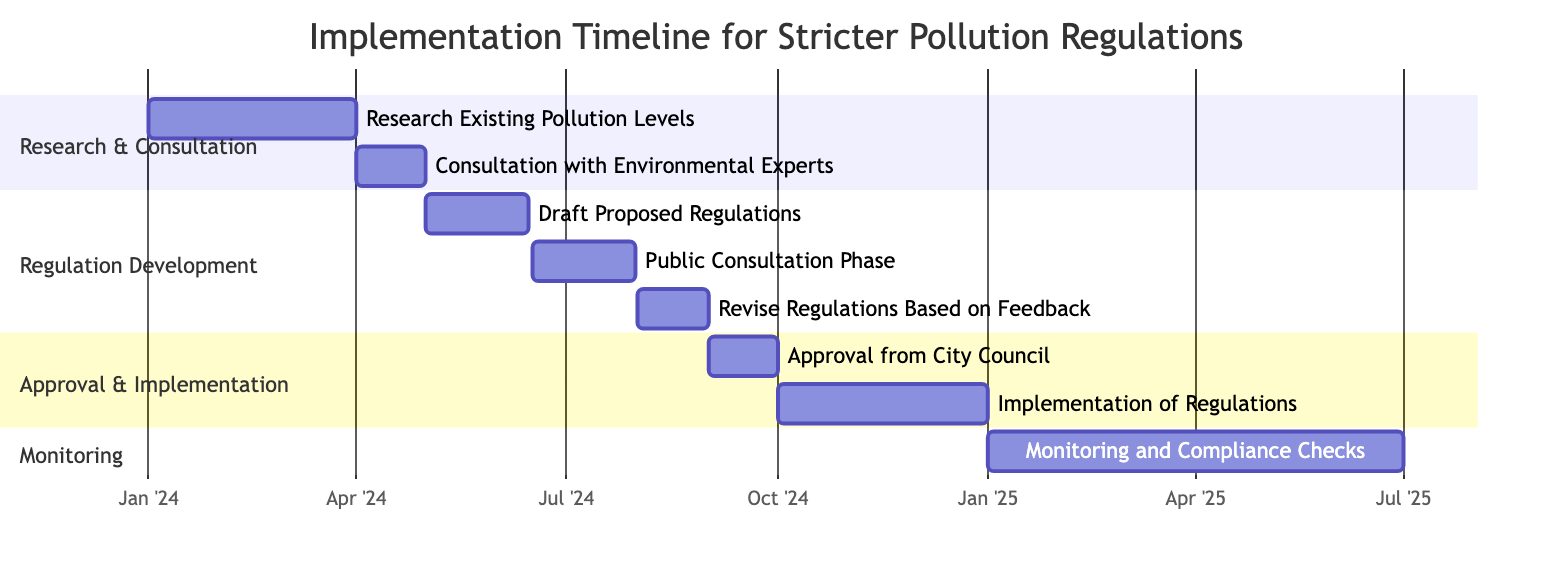What is the duration of the "Research Existing Pollution Levels" task? The "Research Existing Pollution Levels" task starts on January 1, 2024, and ends on March 31, 2024. Therefore, the duration is from January to March, which is 3 months.
Answer: 3 months How many tasks are there in the "Approval & Implementation" section? The "Approval & Implementation" section contains two tasks: "Approval from City Council" and "Implementation of Regulations." Therefore, the total number of tasks in this section is 2.
Answer: 2 When does the "Public Consultation Phase" start? The "Public Consultation Phase" task starts on June 16, 2024. This date can be found directly on the Gantt chart next to the task label.
Answer: June 16, 2024 What is the last task in the timeline? The last task in the timeline is "Monitoring and Compliance Checks," which starts on January 1, 2025, and ends on June 30, 2025. As it is positioned at the end of the timeline, it is identified as the last task.
Answer: Monitoring and Compliance Checks Which task has the longest duration? The "Implementation of Regulations" task has a duration of 3 months, which is the longest compared to other tasks listed in the timeline. The timeline shows multiple tasks with various durations, but this is the maximum duration.
Answer: Implementation of Regulations What is the end date of the "Monitoring and Compliance Checks"? The "Monitoring and Compliance Checks" task ends on June 30, 2025. This information is available in the diagram, where the task is marked with its respective end date.
Answer: June 30, 2025 Which task follows the "Revised Regulations Based on Feedback" task? The task that follows "Revise Regulations Based on Feedback," which ends on August 31, 2024, is "Approval from City Council," starting on September 1, 2024. This can be determined by the sequence of tasks shown in the Gantt chart.
Answer: Approval from City Council How long does the "Monitoring and Compliance Checks" task last? The "Monitoring and Compliance Checks" task lasts for 6 months, starting from January 1, 2025, and ending on June 30, 2025, which can be calculated from its start and end dates displayed in the timeline.
Answer: 6 months What task overlaps with the "Draft Proposed Regulations"? The "Public Consultation Phase" overlaps with the "Draft Proposed Regulations" as it starts on June 16, 2024, while the "Draft Proposed Regulations" ends on June 15, 2024. The timing indicates that they are adjacent but do not overlap during the same time frame.
Answer: None 